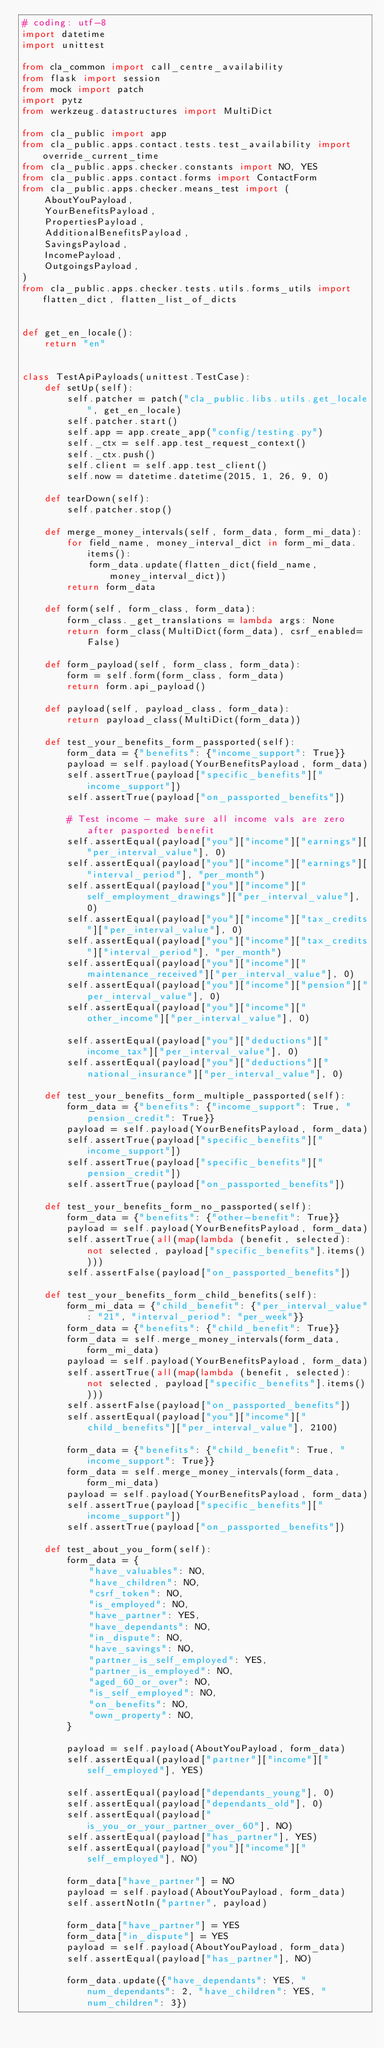<code> <loc_0><loc_0><loc_500><loc_500><_Python_># coding: utf-8
import datetime
import unittest

from cla_common import call_centre_availability
from flask import session
from mock import patch
import pytz
from werkzeug.datastructures import MultiDict

from cla_public import app
from cla_public.apps.contact.tests.test_availability import override_current_time
from cla_public.apps.checker.constants import NO, YES
from cla_public.apps.contact.forms import ContactForm
from cla_public.apps.checker.means_test import (
    AboutYouPayload,
    YourBenefitsPayload,
    PropertiesPayload,
    AdditionalBenefitsPayload,
    SavingsPayload,
    IncomePayload,
    OutgoingsPayload,
)
from cla_public.apps.checker.tests.utils.forms_utils import flatten_dict, flatten_list_of_dicts


def get_en_locale():
    return "en"


class TestApiPayloads(unittest.TestCase):
    def setUp(self):
        self.patcher = patch("cla_public.libs.utils.get_locale", get_en_locale)
        self.patcher.start()
        self.app = app.create_app("config/testing.py")
        self._ctx = self.app.test_request_context()
        self._ctx.push()
        self.client = self.app.test_client()
        self.now = datetime.datetime(2015, 1, 26, 9, 0)

    def tearDown(self):
        self.patcher.stop()

    def merge_money_intervals(self, form_data, form_mi_data):
        for field_name, money_interval_dict in form_mi_data.items():
            form_data.update(flatten_dict(field_name, money_interval_dict))
        return form_data

    def form(self, form_class, form_data):
        form_class._get_translations = lambda args: None
        return form_class(MultiDict(form_data), csrf_enabled=False)

    def form_payload(self, form_class, form_data):
        form = self.form(form_class, form_data)
        return form.api_payload()

    def payload(self, payload_class, form_data):
        return payload_class(MultiDict(form_data))

    def test_your_benefits_form_passported(self):
        form_data = {"benefits": {"income_support": True}}
        payload = self.payload(YourBenefitsPayload, form_data)
        self.assertTrue(payload["specific_benefits"]["income_support"])
        self.assertTrue(payload["on_passported_benefits"])

        # Test income - make sure all income vals are zero after pasported benefit
        self.assertEqual(payload["you"]["income"]["earnings"]["per_interval_value"], 0)
        self.assertEqual(payload["you"]["income"]["earnings"]["interval_period"], "per_month")
        self.assertEqual(payload["you"]["income"]["self_employment_drawings"]["per_interval_value"], 0)
        self.assertEqual(payload["you"]["income"]["tax_credits"]["per_interval_value"], 0)
        self.assertEqual(payload["you"]["income"]["tax_credits"]["interval_period"], "per_month")
        self.assertEqual(payload["you"]["income"]["maintenance_received"]["per_interval_value"], 0)
        self.assertEqual(payload["you"]["income"]["pension"]["per_interval_value"], 0)
        self.assertEqual(payload["you"]["income"]["other_income"]["per_interval_value"], 0)

        self.assertEqual(payload["you"]["deductions"]["income_tax"]["per_interval_value"], 0)
        self.assertEqual(payload["you"]["deductions"]["national_insurance"]["per_interval_value"], 0)

    def test_your_benefits_form_multiple_passported(self):
        form_data = {"benefits": {"income_support": True, "pension_credit": True}}
        payload = self.payload(YourBenefitsPayload, form_data)
        self.assertTrue(payload["specific_benefits"]["income_support"])
        self.assertTrue(payload["specific_benefits"]["pension_credit"])
        self.assertTrue(payload["on_passported_benefits"])

    def test_your_benefits_form_no_passported(self):
        form_data = {"benefits": {"other-benefit": True}}
        payload = self.payload(YourBenefitsPayload, form_data)
        self.assertTrue(all(map(lambda (benefit, selected): not selected, payload["specific_benefits"].items())))
        self.assertFalse(payload["on_passported_benefits"])

    def test_your_benefits_form_child_benefits(self):
        form_mi_data = {"child_benefit": {"per_interval_value": "21", "interval_period": "per_week"}}
        form_data = {"benefits": {"child_benefit": True}}
        form_data = self.merge_money_intervals(form_data, form_mi_data)
        payload = self.payload(YourBenefitsPayload, form_data)
        self.assertTrue(all(map(lambda (benefit, selected): not selected, payload["specific_benefits"].items())))
        self.assertFalse(payload["on_passported_benefits"])
        self.assertEqual(payload["you"]["income"]["child_benefits"]["per_interval_value"], 2100)

        form_data = {"benefits": {"child_benefit": True, "income_support": True}}
        form_data = self.merge_money_intervals(form_data, form_mi_data)
        payload = self.payload(YourBenefitsPayload, form_data)
        self.assertTrue(payload["specific_benefits"]["income_support"])
        self.assertTrue(payload["on_passported_benefits"])

    def test_about_you_form(self):
        form_data = {
            "have_valuables": NO,
            "have_children": NO,
            "csrf_token": NO,
            "is_employed": NO,
            "have_partner": YES,
            "have_dependants": NO,
            "in_dispute": NO,
            "have_savings": NO,
            "partner_is_self_employed": YES,
            "partner_is_employed": NO,
            "aged_60_or_over": NO,
            "is_self_employed": NO,
            "on_benefits": NO,
            "own_property": NO,
        }

        payload = self.payload(AboutYouPayload, form_data)
        self.assertEqual(payload["partner"]["income"]["self_employed"], YES)

        self.assertEqual(payload["dependants_young"], 0)
        self.assertEqual(payload["dependants_old"], 0)
        self.assertEqual(payload["is_you_or_your_partner_over_60"], NO)
        self.assertEqual(payload["has_partner"], YES)
        self.assertEqual(payload["you"]["income"]["self_employed"], NO)

        form_data["have_partner"] = NO
        payload = self.payload(AboutYouPayload, form_data)
        self.assertNotIn("partner", payload)

        form_data["have_partner"] = YES
        form_data["in_dispute"] = YES
        payload = self.payload(AboutYouPayload, form_data)
        self.assertEqual(payload["has_partner"], NO)

        form_data.update({"have_dependants": YES, "num_dependants": 2, "have_children": YES, "num_children": 3})</code> 